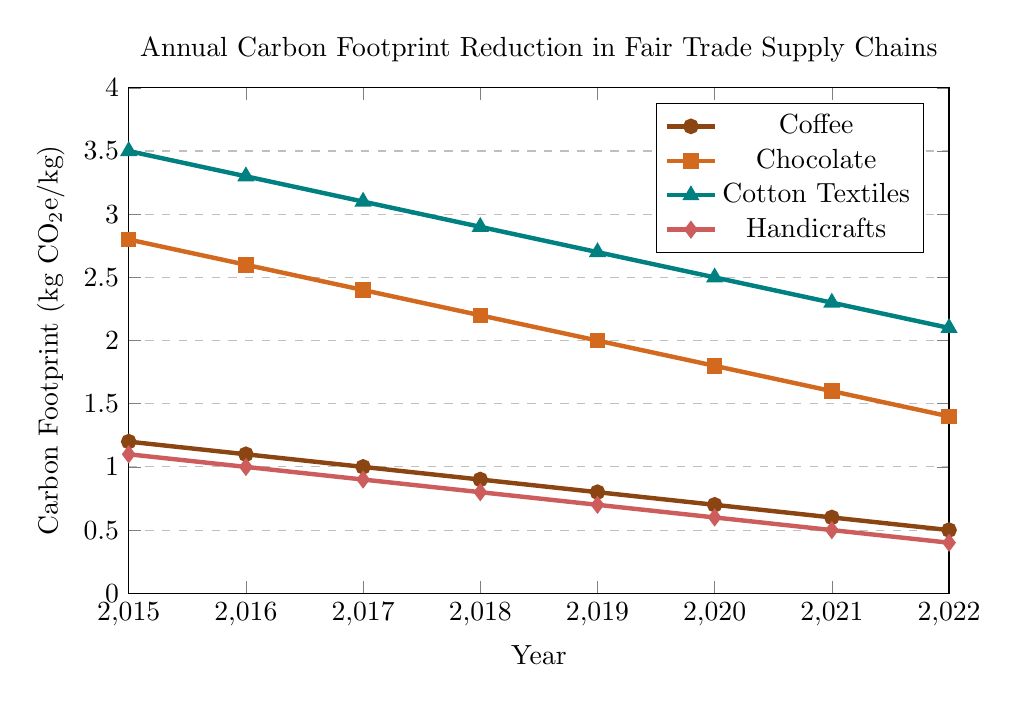What's the trend for the carbon footprint reduction in Coffee from 2015 to 2022? The carbon footprint for Coffee shows a decreasing trend from 1.2 kg CO2e/kg in 2015 to 0.5 kg CO2e/kg in 2022.
Answer: Decreasing Which product had the highest carbon footprint in 2015? In 2015, Cotton Textiles had the highest carbon footprint with a value of 3.5 kg CO2e/kg.
Answer: Cotton Textiles What is the average carbon footprint for Handicrafts from 2015 to 2022? The sum of the carbon footprints for Handicrafts over these years is (1.1 + 1.0 + 0.9 + 0.8 + 0.7 + 0.6 + 0.5 + 0.4) = 6.0 kg CO2e/kg. There are 8 years, so the average is 6.0 / 8 = 0.75 kg CO2e/kg.
Answer: 0.75 kg CO2e/kg By how much did the carbon footprint for Chocolate decrease from 2015 to 2022? The carbon footprint for Chocolate decreased from 2.8 kg CO2e/kg in 2015 to 1.4 kg CO2e/kg in 2022. The decrease is 2.8 - 1.4 = 1.4 kg CO2e/kg.
Answer: 1.4 kg CO2e/kg Which product had the largest reduction in carbon footprint from 2015 to 2022? By comparing the initial and final values: Coffee (1.2 - 0.5 = 0.7), Chocolate (2.8 - 1.4 = 1.4), Cotton Textiles (3.5 - 2.1 = 1.4), Handicrafts (1.1 - 0.4 = 0.7), both Chocolate and Cotton Textiles had the largest reduction of 1.4 kg CO2e/kg.
Answer: Chocolate and Cotton Textiles What’s the difference between the carbon footprint values of Cotton Textiles and Handicrafts in 2020? In 2020, the carbon footprint for Cotton Textiles is 2.5 kg CO2e/kg and for Handicrafts is 0.6 kg CO2e/kg. The difference is 2.5 - 0.6 = 1.9 kg CO2e/kg.
Answer: 1.9 kg CO2e/kg In which year did Coffee achieve a carbon footprint lower than 1 kg CO2e/kg for the first time? Coffee's carbon footprint first dropped below 1 kg CO2e/kg in 2017, when it reached 1.0 kg CO2e/kg.
Answer: 2017 How many products had a carbon footprint below 1 kg CO2e/kg by 2022? By 2022, Coffee (0.5 kg CO2e/kg) and Handicrafts (0.4 kg CO2e/kg) both have carbon footprints below 1 kg CO2e/kg.
Answer: 2 products 